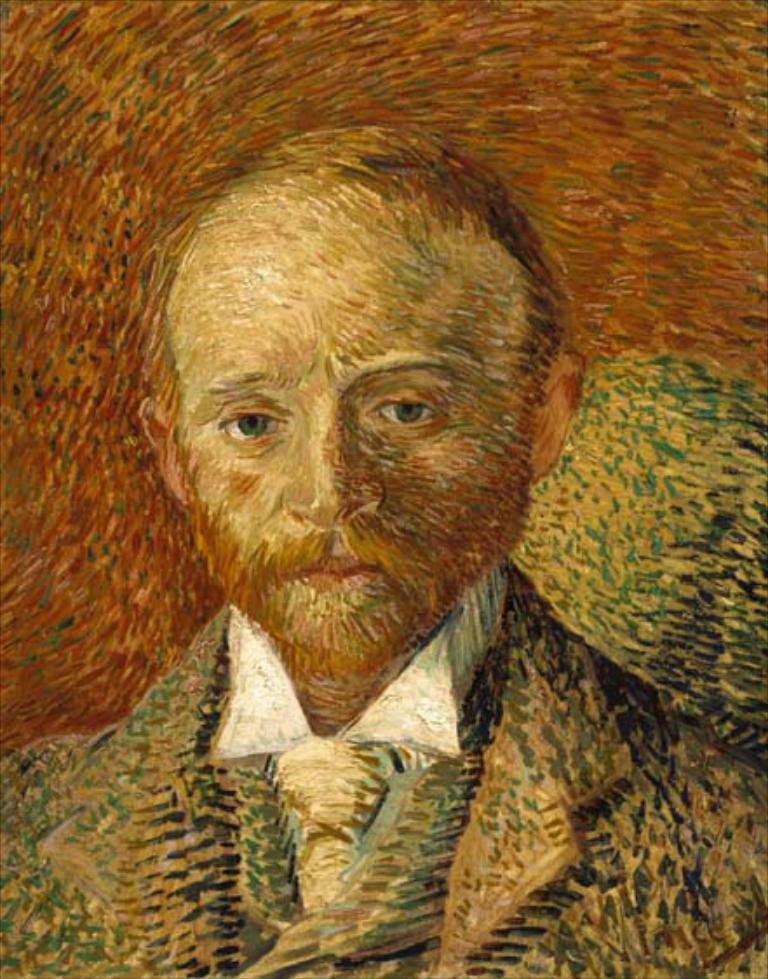What is the main subject of the image? There is a painting of a person in the image. What type of dress is the person wearing in the painting, and how does it help them perform magic while they sleep? There is no information about the person's dress, their ability to perform magic, or their sleeping habits in the image. 